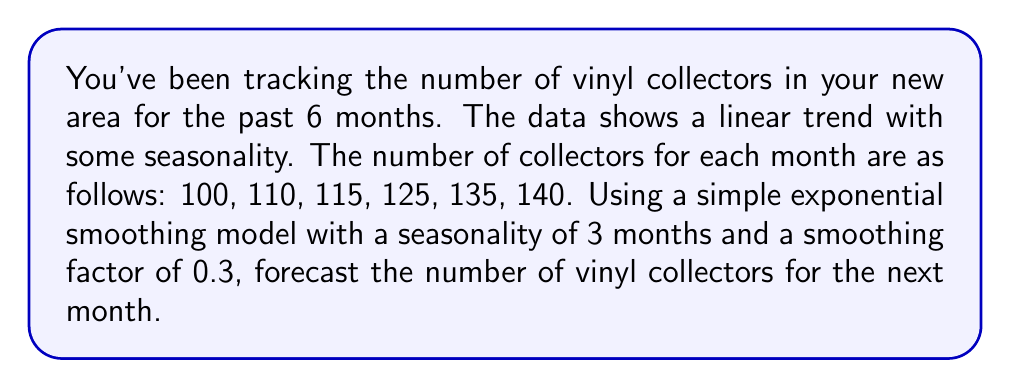Can you solve this math problem? To solve this problem, we'll use the simple exponential smoothing model with seasonality. The formula for this model is:

$$F_{t+1} = \alpha(Y_t - S_{t-L}) + (1-\alpha)F_t$$

Where:
$F_{t+1}$ is the forecast for the next period
$\alpha$ is the smoothing factor (0.3 in this case)
$Y_t$ is the actual value for the current period
$S_{t-L}$ is the seasonal factor for the current period
$L$ is the length of seasonality (3 months in this case)
$F_t$ is the forecast for the current period

Steps:

1. Calculate the seasonal factors:
   For month 1: $S_1 = 100 - 110 = -10$
   For month 2: $S_2 = 110 - 115 = -5$
   For month 3: $S_3 = 115 - 125 = -10$

2. Initialize the forecast:
   $F_1 = 100$

3. Calculate subsequent forecasts:
   $F_2 = 0.3(110 - (-10)) + 0.7(100) = 106$
   $F_3 = 0.3(115 - (-5)) + 0.7(106) = 112.7$
   $F_4 = 0.3(125 - (-10)) + 0.7(112.7) = 119.89$
   $F_5 = 0.3(135 - (-10)) + 0.7(119.89) = 127.923$
   $F_6 = 0.3(140 - (-5)) + 0.7(127.923) = 134.5461$

4. Forecast for month 7:
   $F_7 = 0.3(140 - (-10)) + 0.7(134.5461) = 139.1823$

Therefore, the forecast for the number of vinyl collectors in the next month (month 7) is approximately 139.
Answer: 139 vinyl collectors 